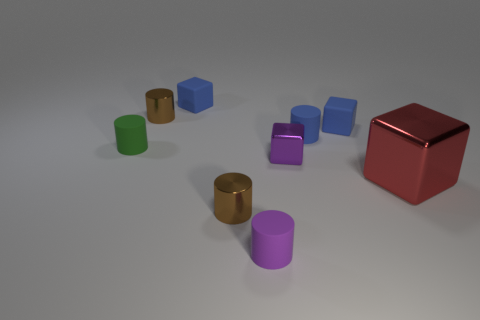The other metal object that is the same shape as the large object is what size?
Provide a short and direct response. Small. What is the material of the tiny cube that is left of the tiny blue matte cylinder and behind the small green cylinder?
Make the answer very short. Rubber. Are there the same number of purple matte things in front of the tiny blue cylinder and tiny purple matte cylinders?
Offer a terse response. Yes. What number of things are either rubber cylinders behind the purple cube or tiny gray metallic spheres?
Make the answer very short. 2. Is the color of the metallic cube that is on the right side of the purple shiny thing the same as the small shiny block?
Ensure brevity in your answer.  No. There is a brown shiny thing behind the green rubber thing; what is its size?
Offer a terse response. Small. The tiny matte thing in front of the brown cylinder in front of the small green object is what shape?
Your response must be concise. Cylinder. There is another metal thing that is the same shape as the big object; what is its color?
Your response must be concise. Purple. Is the size of the brown metal thing that is in front of the green cylinder the same as the purple shiny cube?
Your response must be concise. Yes. What shape is the small object that is the same color as the tiny shiny block?
Keep it short and to the point. Cylinder. 